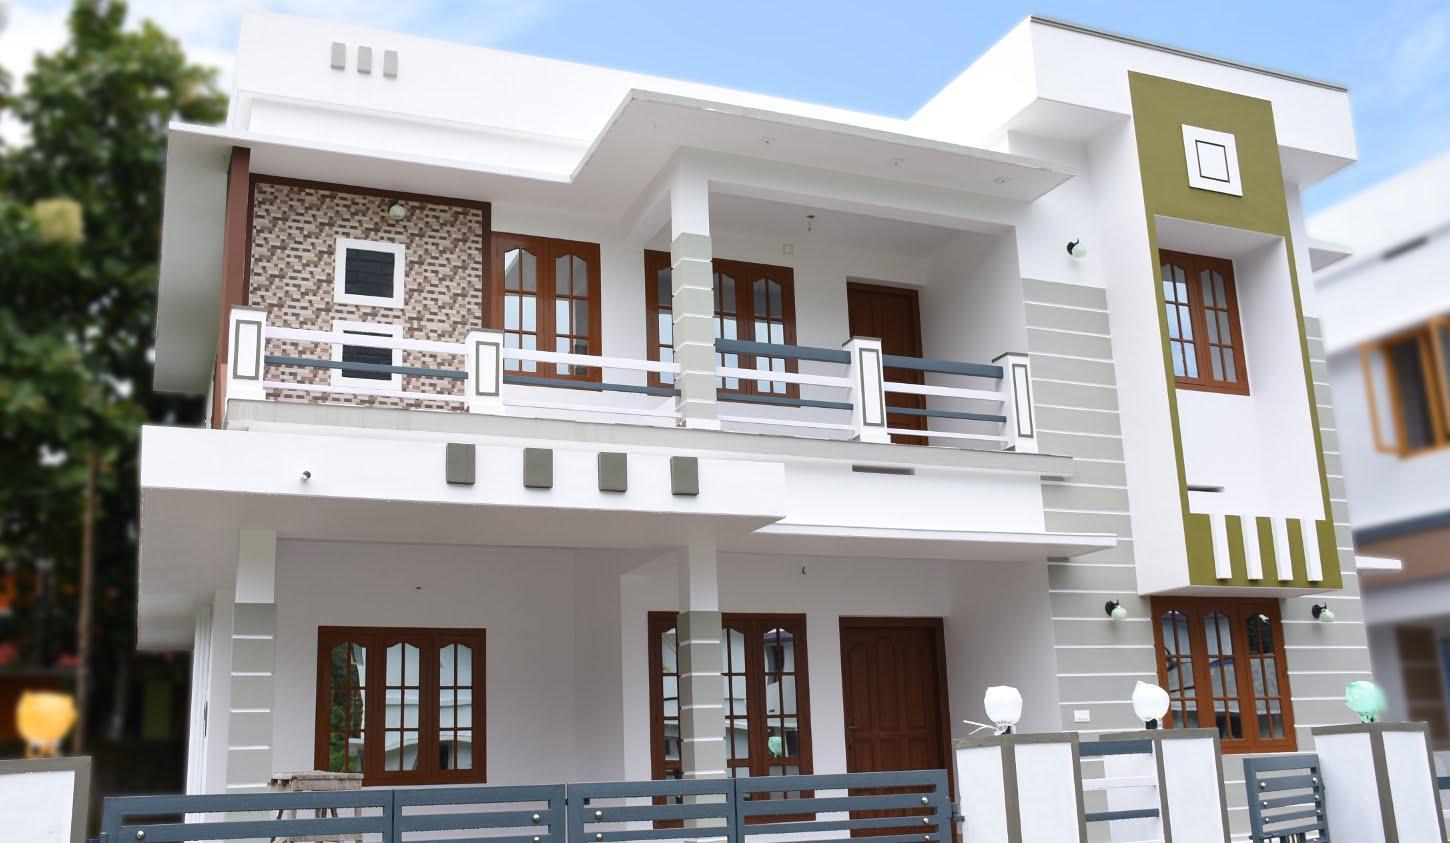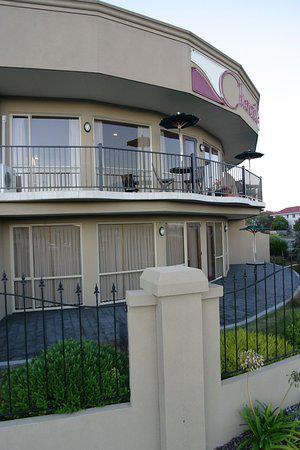The first image is the image on the left, the second image is the image on the right. Given the left and right images, does the statement "One of the balconies has a horizontal design balcony railing." hold true? Answer yes or no. Yes. 